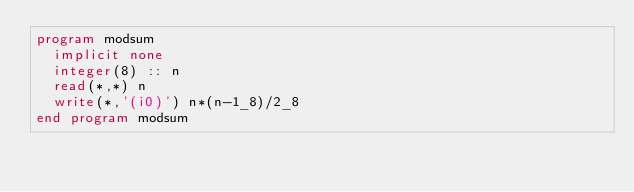Convert code to text. <code><loc_0><loc_0><loc_500><loc_500><_FORTRAN_>program modsum
  implicit none
  integer(8) :: n
  read(*,*) n
  write(*,'(i0)') n*(n-1_8)/2_8
end program modsum</code> 